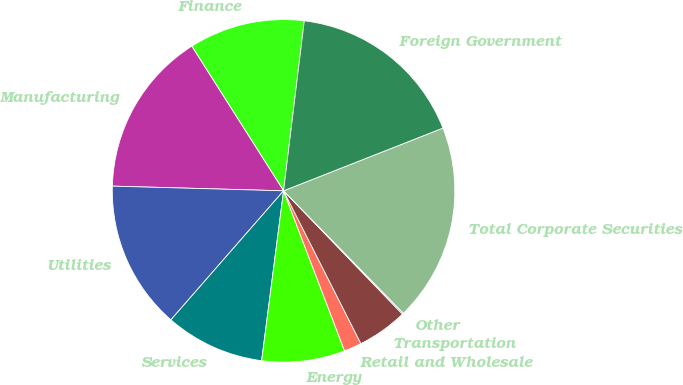<chart> <loc_0><loc_0><loc_500><loc_500><pie_chart><fcel>Finance<fcel>Manufacturing<fcel>Utilities<fcel>Services<fcel>Energy<fcel>Retail and Wholesale<fcel>Transportation<fcel>Other<fcel>Total Corporate Securities<fcel>Foreign Government<nl><fcel>10.93%<fcel>15.56%<fcel>14.01%<fcel>9.38%<fcel>7.84%<fcel>1.66%<fcel>4.75%<fcel>0.12%<fcel>18.64%<fcel>17.1%<nl></chart> 